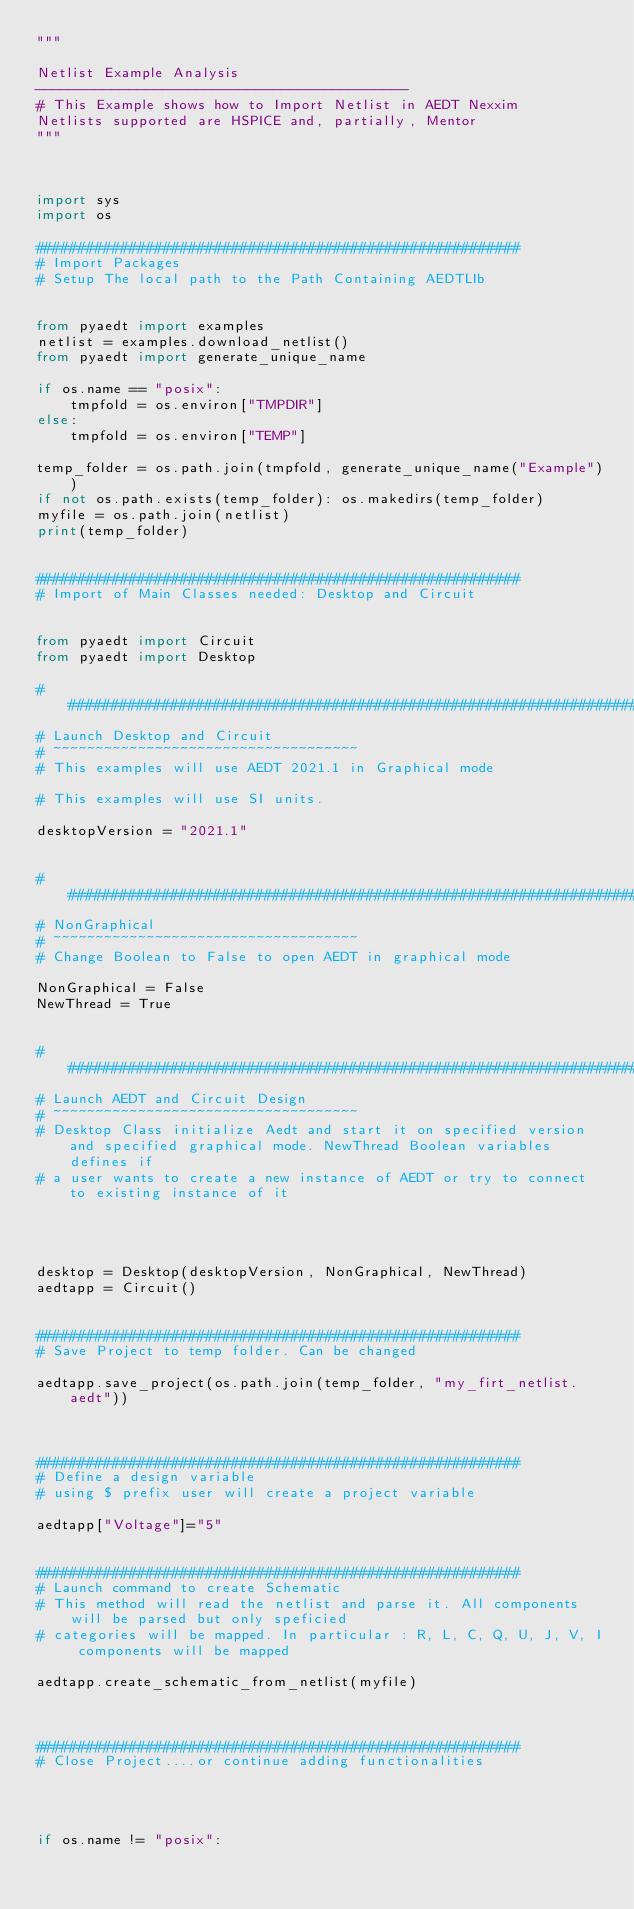Convert code to text. <code><loc_0><loc_0><loc_500><loc_500><_Python_>"""

Netlist Example Analysis
--------------------------------------------
# This Example shows how to Import Netlist in AEDT Nexxim
Netlists supported are HSPICE and, partially, Mentor
"""



import sys
import os

#########################################################
# Import Packages
# Setup The local path to the Path Containing AEDTLIb


from pyaedt import examples
netlist = examples.download_netlist()
from pyaedt import generate_unique_name

if os.name == "posix":
    tmpfold = os.environ["TMPDIR"]
else:
    tmpfold = os.environ["TEMP"]

temp_folder = os.path.join(tmpfold, generate_unique_name("Example"))
if not os.path.exists(temp_folder): os.makedirs(temp_folder)
myfile = os.path.join(netlist)
print(temp_folder)


#########################################################
# Import of Main Classes needed: Desktop and Circuit


from pyaedt import Circuit
from pyaedt import Desktop

###############################################################################
# Launch Desktop and Circuit
# ~~~~~~~~~~~~~~~~~~~~~~~~~~~~~~~~~~~~
# This examples will use AEDT 2021.1 in Graphical mode

# This examples will use SI units.

desktopVersion = "2021.1"


###############################################################################
# NonGraphical
# ~~~~~~~~~~~~~~~~~~~~~~~~~~~~~~~~~~~~
# Change Boolean to False to open AEDT in graphical mode

NonGraphical = False
NewThread = True


###############################################################################
# Launch AEDT and Circuit Design
# ~~~~~~~~~~~~~~~~~~~~~~~~~~~~~~~~~~~~
# Desktop Class initialize Aedt and start it on specified version and specified graphical mode. NewThread Boolean variables defines if
# a user wants to create a new instance of AEDT or try to connect to existing instance of it




desktop = Desktop(desktopVersion, NonGraphical, NewThread)
aedtapp = Circuit()


#########################################################
# Save Project to temp folder. Can be changed

aedtapp.save_project(os.path.join(temp_folder, "my_firt_netlist.aedt"))



#########################################################
# Define a design variable
# using $ prefix user will create a project variable

aedtapp["Voltage"]="5"


#########################################################
# Launch command to create Schematic
# This method will read the netlist and parse it. All components will be parsed but only speficied
# categories will be mapped. In particular : R, L, C, Q, U, J, V, I components will be mapped

aedtapp.create_schematic_from_netlist(myfile)



#########################################################
# Close Project....or continue adding functionalities




if os.name != "posix":</code> 